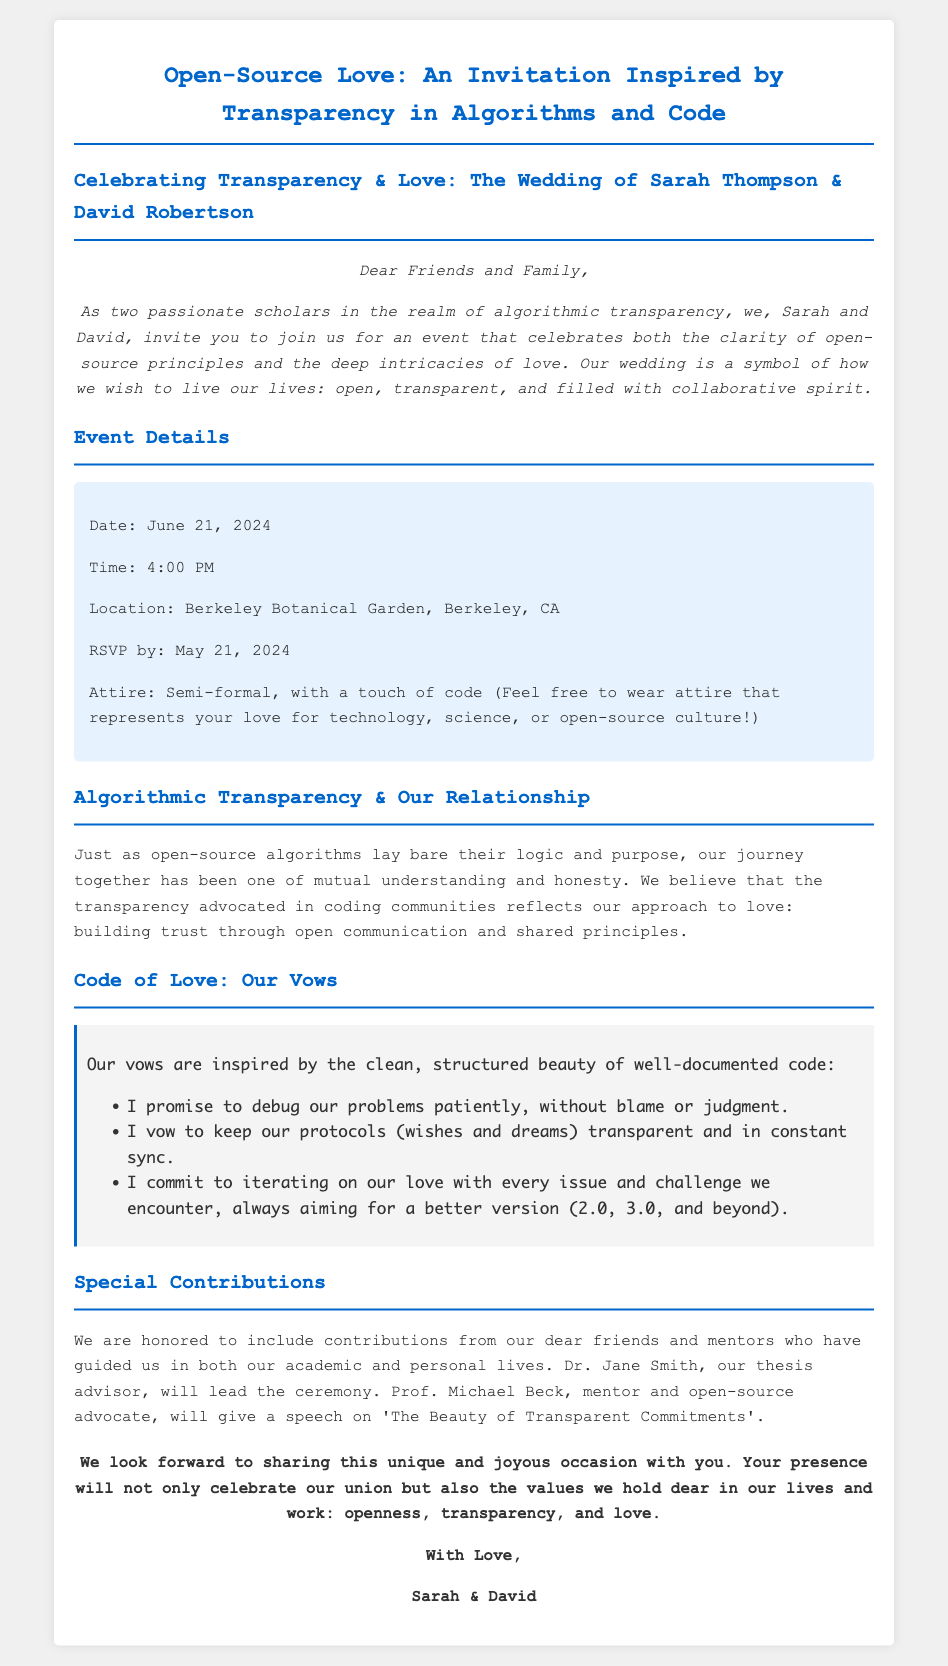what is the date of the wedding? The date of the wedding is explicitly stated as June 21, 2024.
Answer: June 21, 2024 who will lead the ceremony? The document mentions that Dr. Jane Smith will lead the ceremony.
Answer: Dr. Jane Smith what is the venue of the event? The location for the wedding is clearly stated as Berkeley Botanical Garden, Berkeley, CA.
Answer: Berkeley Botanical Garden, Berkeley, CA what time does the wedding start? The starting time of the wedding is provided in the document as 4:00 PM.
Answer: 4:00 PM what is the RSVP deadline? The RSVP deadline is specified as May 21, 2024.
Answer: May 21, 2024 what style of attire is requested? The document states that the attire should be semi-formal, with a touch of code.
Answer: Semi-formal, with a touch of code what is the theme of the wedding? The theme is inspired by algorithmic transparency and open-source principles.
Answer: Open-source love and transparency how do Sarah and David's vows relate to their work? The vows highlight principles of transparency and collaboration, reflecting their approach to both love and academia.
Answer: Mutual understanding and open communication who has a speaking role at the wedding? Prof. Michael Beck will give a speech on 'The Beauty of Transparent Commitments'.
Answer: Prof. Michael Beck 